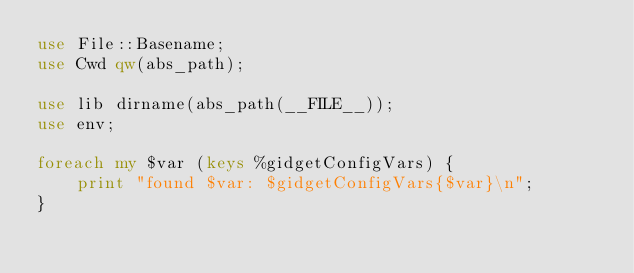<code> <loc_0><loc_0><loc_500><loc_500><_Perl_>use File::Basename;
use Cwd qw(abs_path);

use lib dirname(abs_path(__FILE__));
use env;

foreach my $var (keys %gidgetConfigVars) {
    print "found $var: $gidgetConfigVars{$var}\n";
}
</code> 